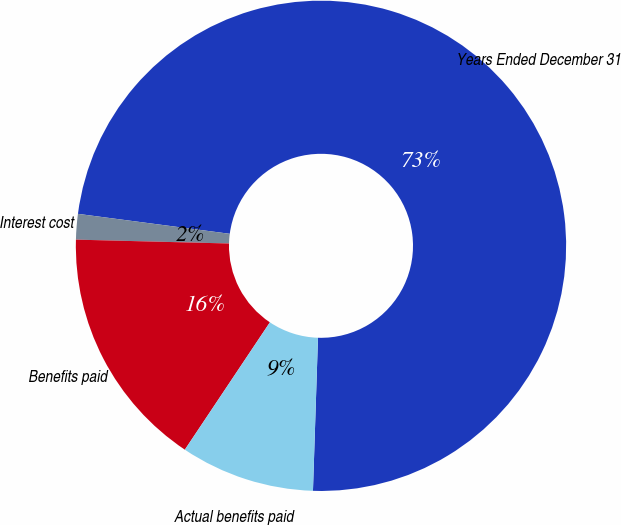Convert chart to OTSL. <chart><loc_0><loc_0><loc_500><loc_500><pie_chart><fcel>Years Ended December 31<fcel>Interest cost<fcel>Benefits paid<fcel>Actual benefits paid<nl><fcel>73.44%<fcel>1.68%<fcel>16.03%<fcel>8.85%<nl></chart> 